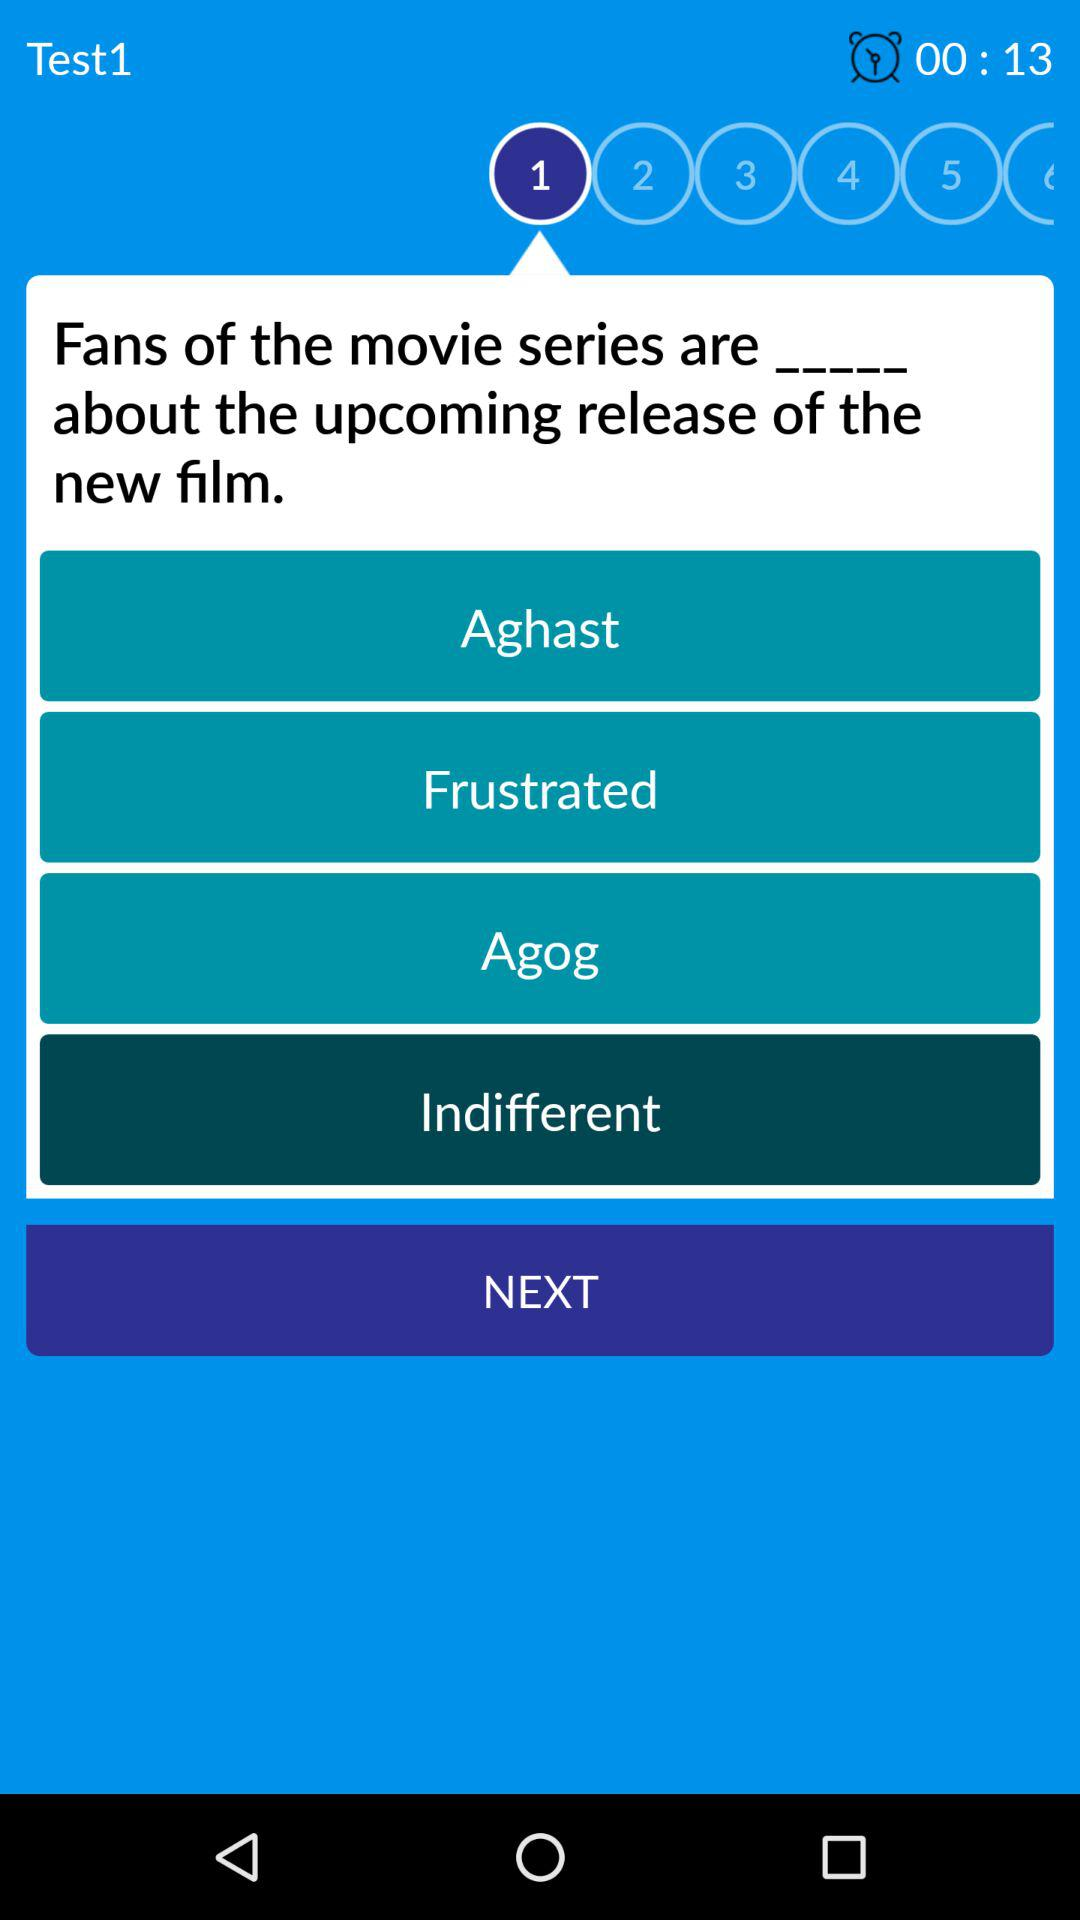Which option is selected out of four? The selected option out of four is "Indifferent". 